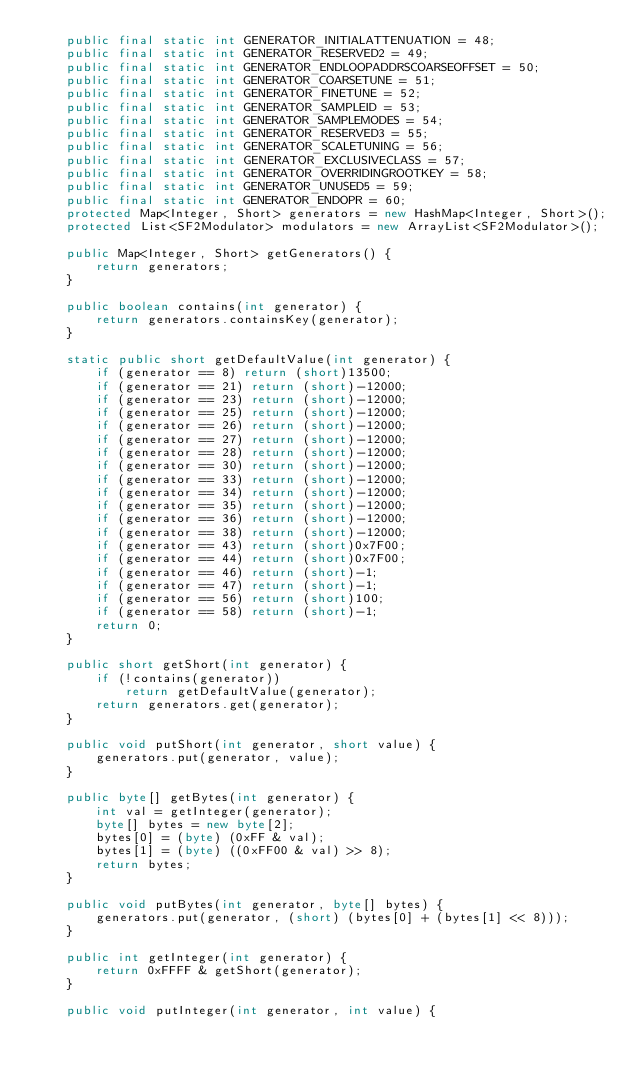Convert code to text. <code><loc_0><loc_0><loc_500><loc_500><_Java_>    public final static int GENERATOR_INITIALATTENUATION = 48;
    public final static int GENERATOR_RESERVED2 = 49;
    public final static int GENERATOR_ENDLOOPADDRSCOARSEOFFSET = 50;
    public final static int GENERATOR_COARSETUNE = 51;
    public final static int GENERATOR_FINETUNE = 52;
    public final static int GENERATOR_SAMPLEID = 53;
    public final static int GENERATOR_SAMPLEMODES = 54;
    public final static int GENERATOR_RESERVED3 = 55;
    public final static int GENERATOR_SCALETUNING = 56;
    public final static int GENERATOR_EXCLUSIVECLASS = 57;
    public final static int GENERATOR_OVERRIDINGROOTKEY = 58;
    public final static int GENERATOR_UNUSED5 = 59;
    public final static int GENERATOR_ENDOPR = 60;
    protected Map<Integer, Short> generators = new HashMap<Integer, Short>();
    protected List<SF2Modulator> modulators = new ArrayList<SF2Modulator>();

    public Map<Integer, Short> getGenerators() {
        return generators;
    }

    public boolean contains(int generator) {
        return generators.containsKey(generator);
    }

    static public short getDefaultValue(int generator) {
        if (generator == 8) return (short)13500;
        if (generator == 21) return (short)-12000;
        if (generator == 23) return (short)-12000;
        if (generator == 25) return (short)-12000;
        if (generator == 26) return (short)-12000;
        if (generator == 27) return (short)-12000;
        if (generator == 28) return (short)-12000;
        if (generator == 30) return (short)-12000;
        if (generator == 33) return (short)-12000;
        if (generator == 34) return (short)-12000;
        if (generator == 35) return (short)-12000;
        if (generator == 36) return (short)-12000;
        if (generator == 38) return (short)-12000;
        if (generator == 43) return (short)0x7F00;
        if (generator == 44) return (short)0x7F00;
        if (generator == 46) return (short)-1;
        if (generator == 47) return (short)-1;
        if (generator == 56) return (short)100;
        if (generator == 58) return (short)-1;
        return 0;
    }

    public short getShort(int generator) {
        if (!contains(generator))
            return getDefaultValue(generator);
        return generators.get(generator);
    }

    public void putShort(int generator, short value) {
        generators.put(generator, value);
    }

    public byte[] getBytes(int generator) {
        int val = getInteger(generator);
        byte[] bytes = new byte[2];
        bytes[0] = (byte) (0xFF & val);
        bytes[1] = (byte) ((0xFF00 & val) >> 8);
        return bytes;
    }

    public void putBytes(int generator, byte[] bytes) {
        generators.put(generator, (short) (bytes[0] + (bytes[1] << 8)));
    }

    public int getInteger(int generator) {
        return 0xFFFF & getShort(generator);
    }

    public void putInteger(int generator, int value) {</code> 